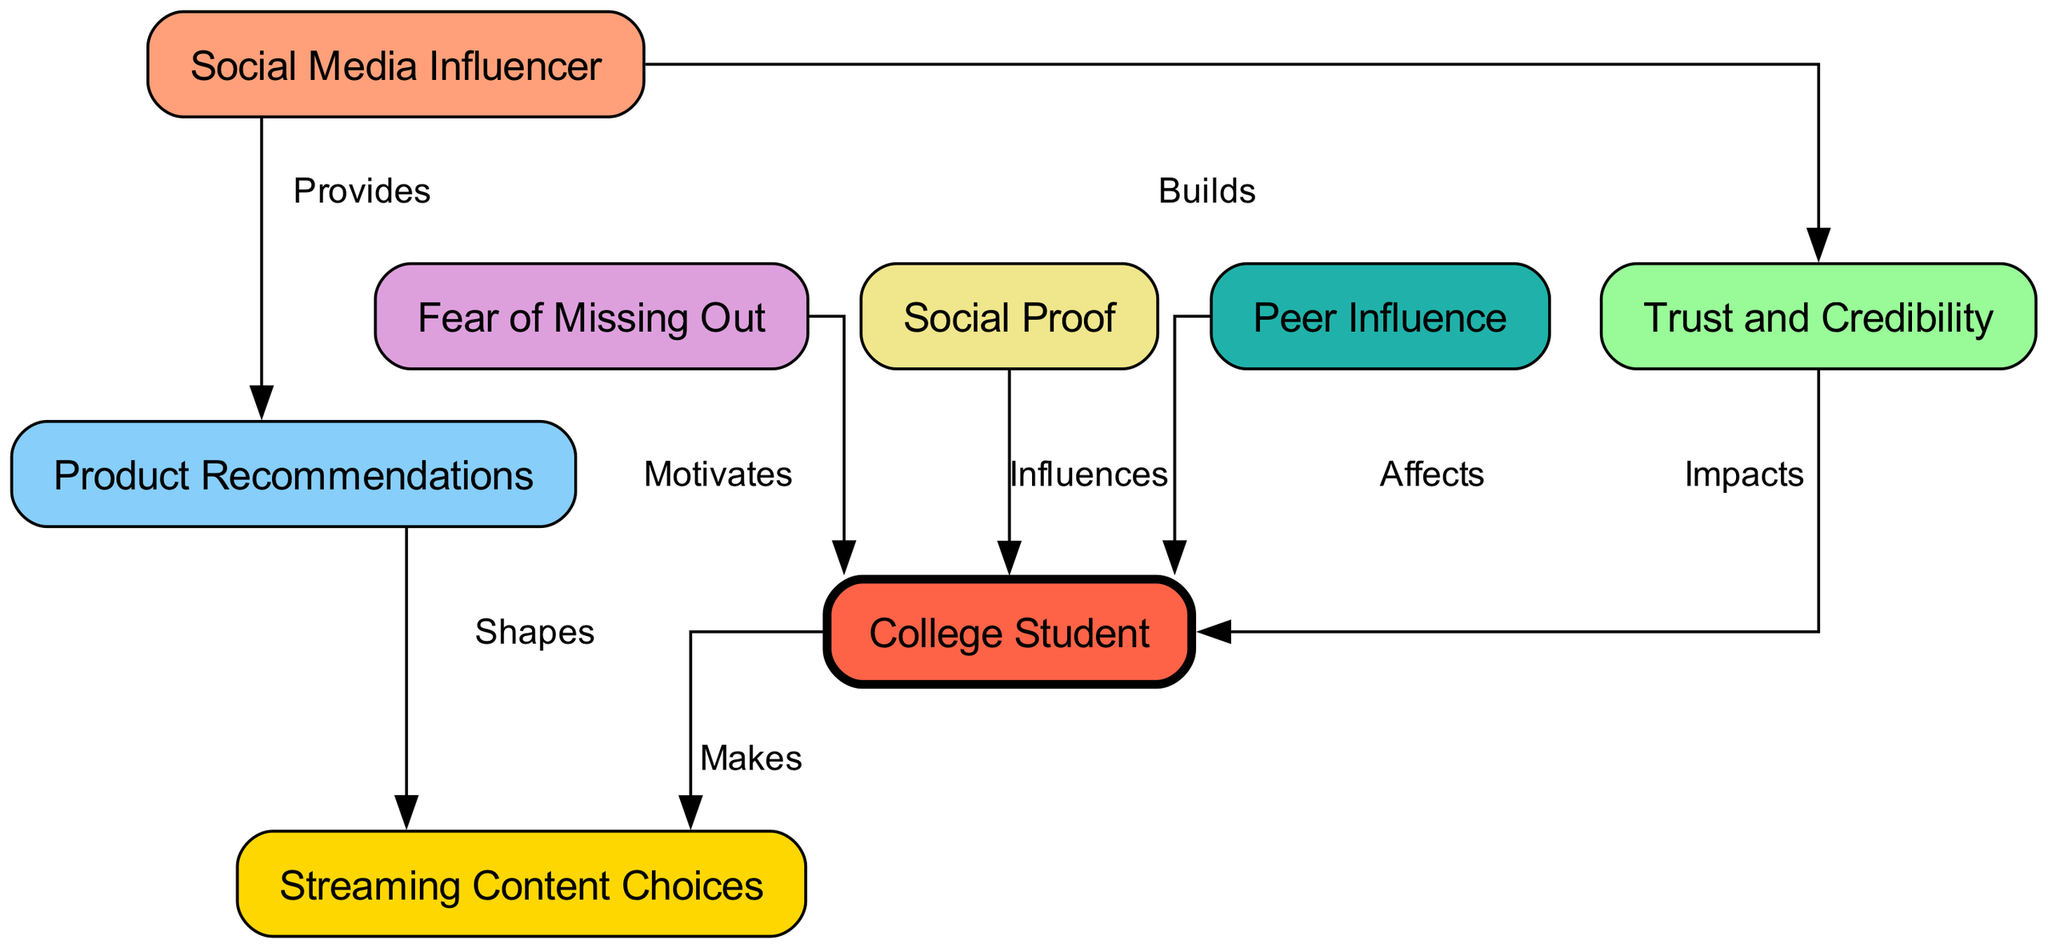What are the total number of nodes in the diagram? The diagram lists 8 distinct nodes: Social Media Influencer, Trust and Credibility, Product Recommendations, Fear of Missing Out, Social Proof, College Student, Streaming Content Choices, and Peer Influence. Thus, the total is 8.
Answer: 8 Which node impacts the College Student? The node 'Trust and Credibility' has a direct edge labeled 'Impacts' pointing to 'College Student', indicating its effect on them.
Answer: Trust and Credibility What does the influencer provide? According to the diagram, there's an edge from 'Social Media Influencer' to 'Product Recommendations' labeled 'Provides', showing the direct relationship.
Answer: Product Recommendations How does FOMO affect the College Student? The diagram shows a relationship between 'Fear of Missing Out' and 'College Student', with an edge marked 'Motivates', indicating a motivational influence.
Answer: Motivates Which node has the most connections to the College Student? The 'College Student' node is the endpoint for relationships from 'Trust and Credibility', 'Fear of Missing Out', 'Social Proof', and 'Peer Influence', making it central to various influences.
Answer: College Student What role does social proof play in influencing the College Student? The edge from 'Social Proof' to 'College Student' labeled 'Influences' indicates that social proof directly affects the decisions of the College Student.
Answer: Influences How is the College Student related to streaming choices? The diagram illustrates that 'College Student' makes 'Streaming Content Choices', establishing a direct relationship where the student actively decides what to watch.
Answer: Makes Which node shapes streaming choices? The edge from 'Product Recommendations' to 'Streaming Content Choices' specifies that recommendations help to shape the choices of streaming content made by the College Student.
Answer: Shapes 